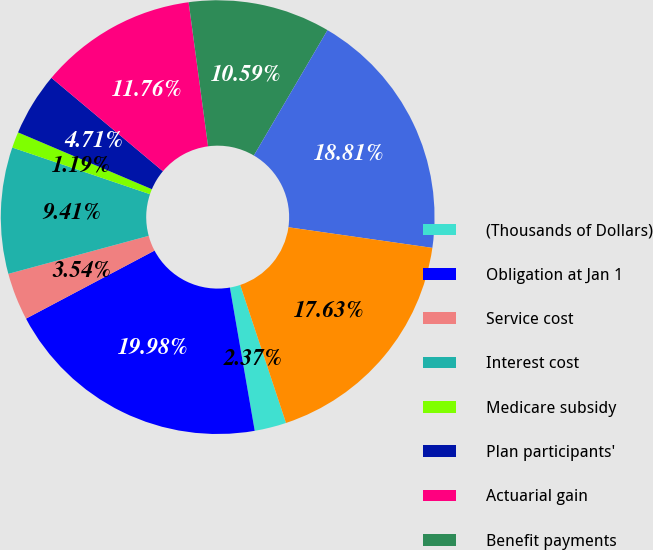<chart> <loc_0><loc_0><loc_500><loc_500><pie_chart><fcel>(Thousands of Dollars)<fcel>Obligation at Jan 1<fcel>Service cost<fcel>Interest cost<fcel>Medicare subsidy<fcel>Plan participants'<fcel>Actuarial gain<fcel>Benefit payments<fcel>Obligation at Dec 31<fcel>Fair value of plan assets at<nl><fcel>2.37%<fcel>19.98%<fcel>3.54%<fcel>9.41%<fcel>1.19%<fcel>4.71%<fcel>11.76%<fcel>10.59%<fcel>18.81%<fcel>17.63%<nl></chart> 